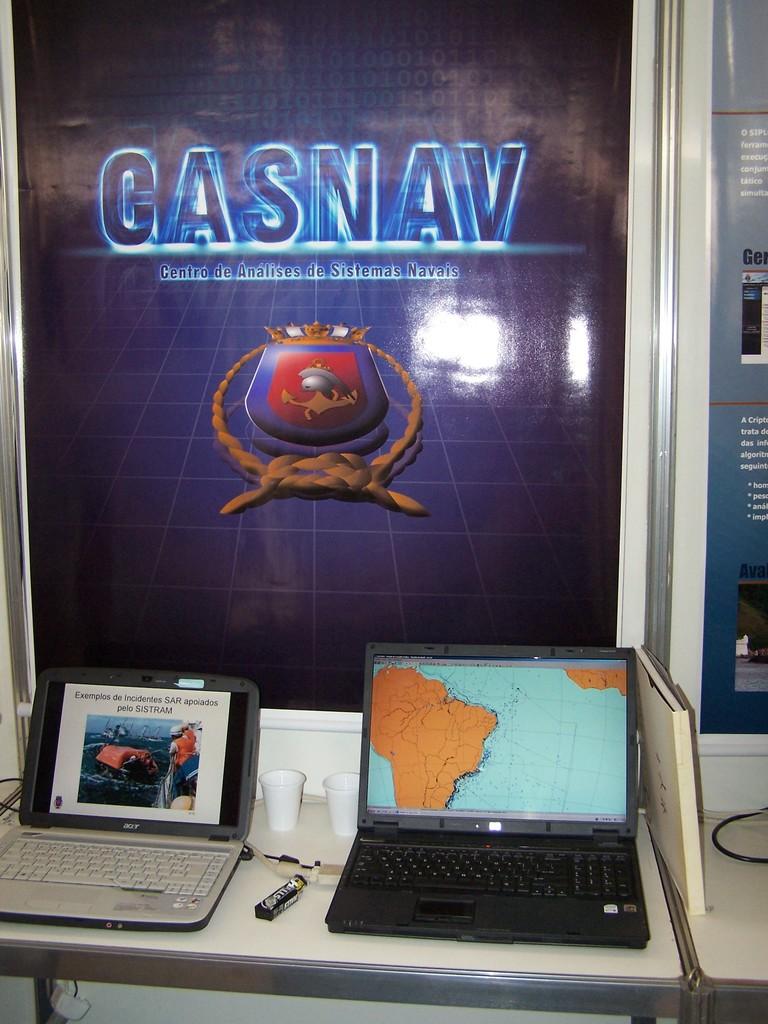What is the company being displayed?
Offer a terse response. Gasnav. 